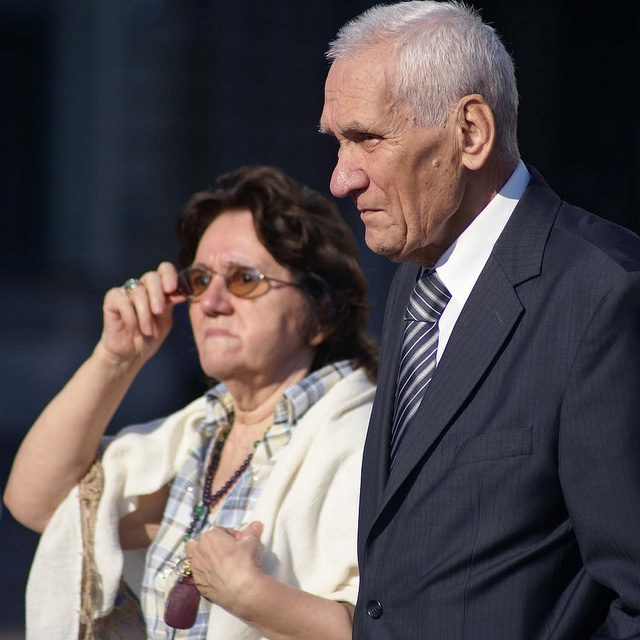Describe the objects in this image and their specific colors. I can see people in black, tan, and gray tones, people in black, lightgray, tan, and gray tones, and tie in black, gray, navy, and darkgray tones in this image. 